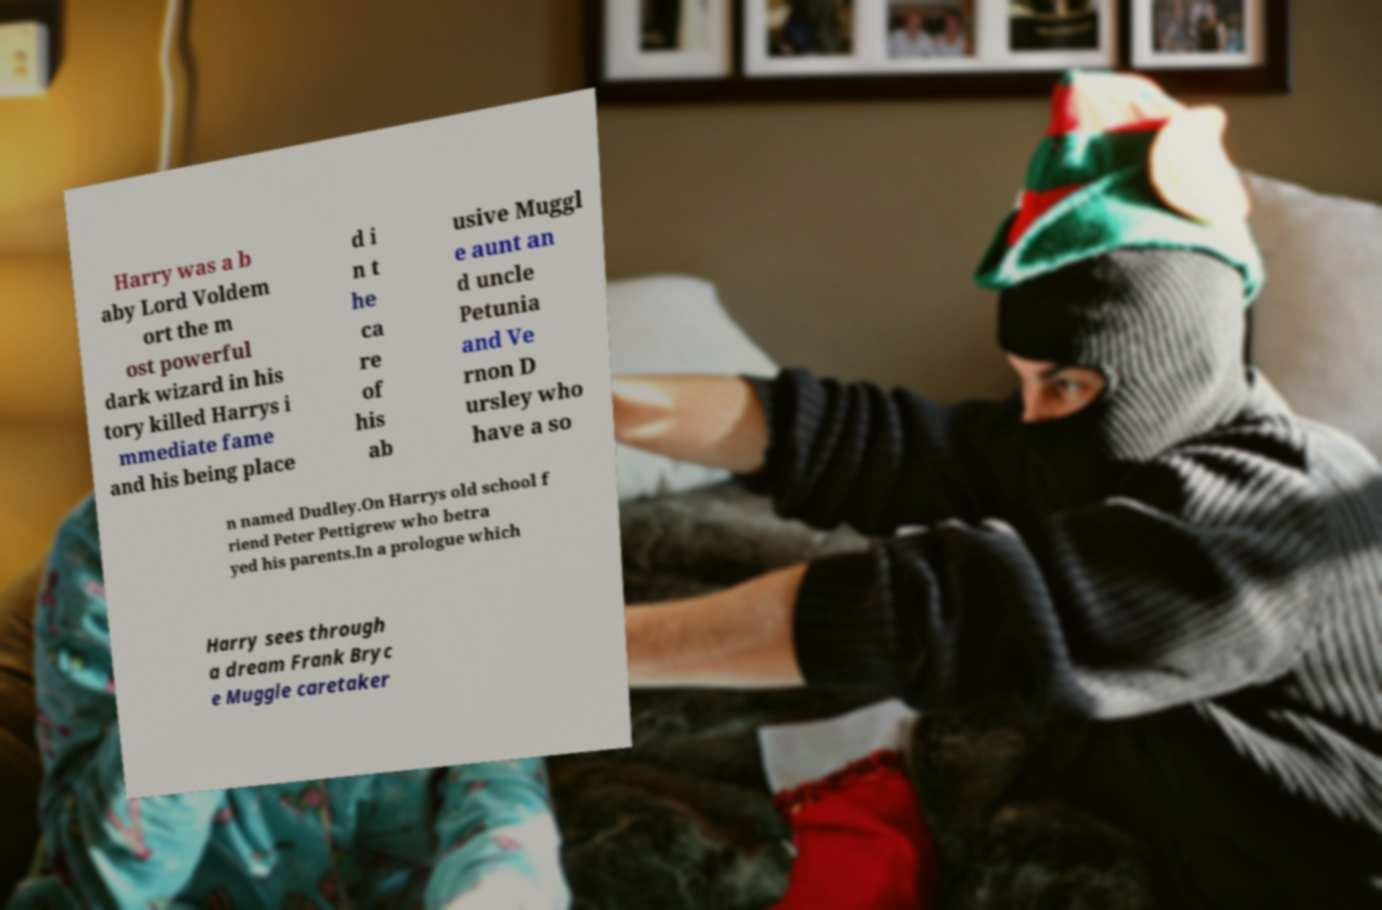Could you extract and type out the text from this image? Harry was a b aby Lord Voldem ort the m ost powerful dark wizard in his tory killed Harrys i mmediate fame and his being place d i n t he ca re of his ab usive Muggl e aunt an d uncle Petunia and Ve rnon D ursley who have a so n named Dudley.On Harrys old school f riend Peter Pettigrew who betra yed his parents.In a prologue which Harry sees through a dream Frank Bryc e Muggle caretaker 